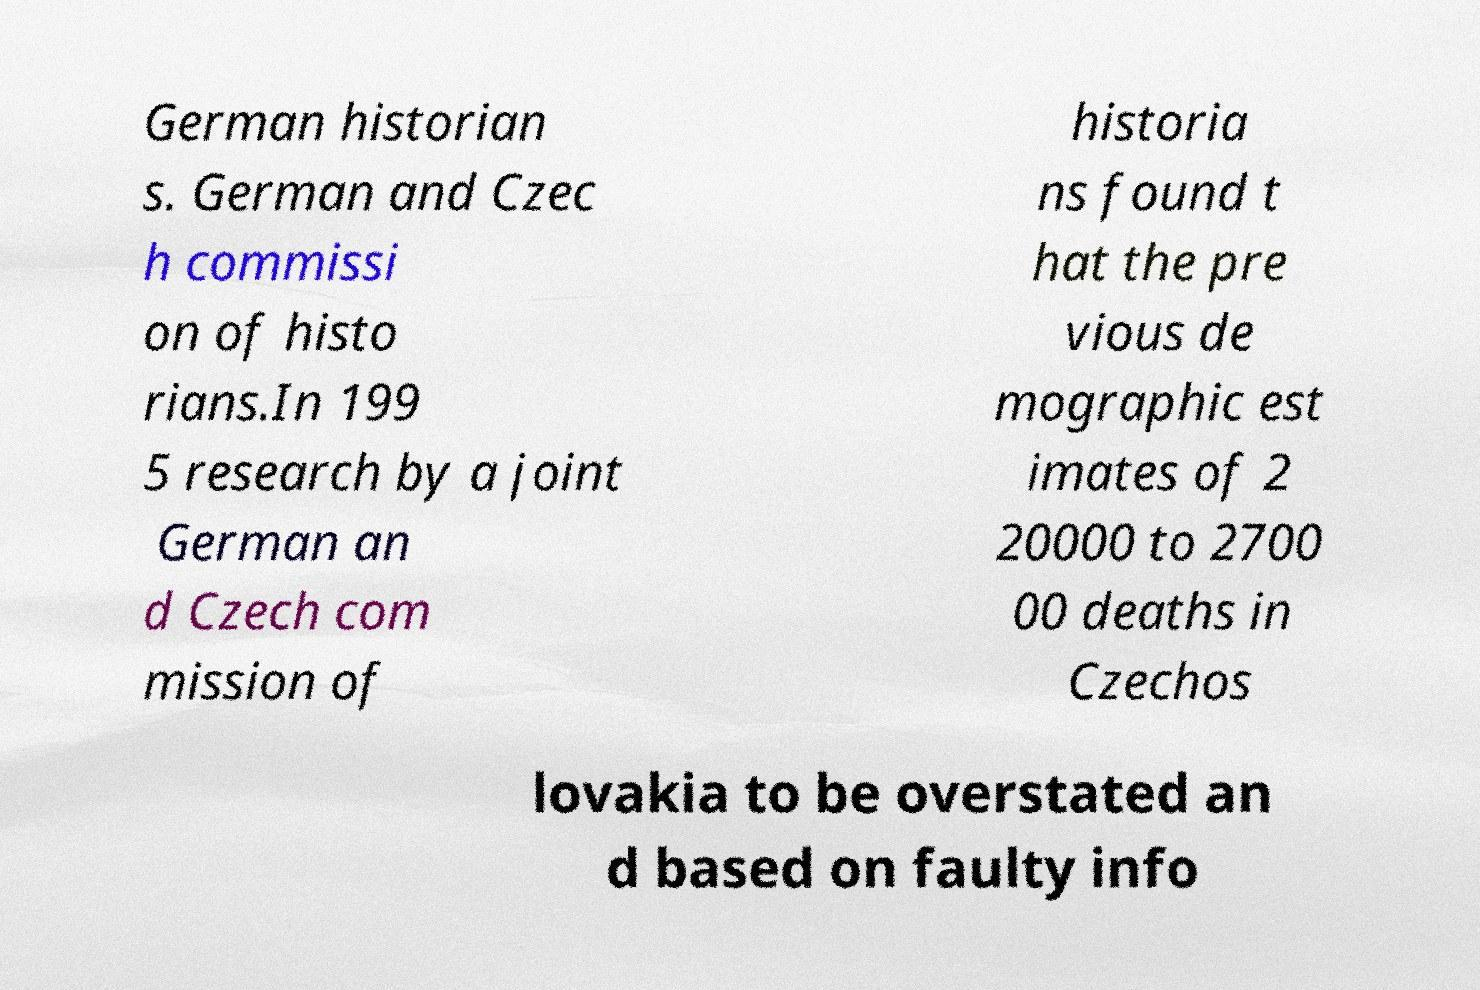Could you extract and type out the text from this image? German historian s. German and Czec h commissi on of histo rians.In 199 5 research by a joint German an d Czech com mission of historia ns found t hat the pre vious de mographic est imates of 2 20000 to 2700 00 deaths in Czechos lovakia to be overstated an d based on faulty info 